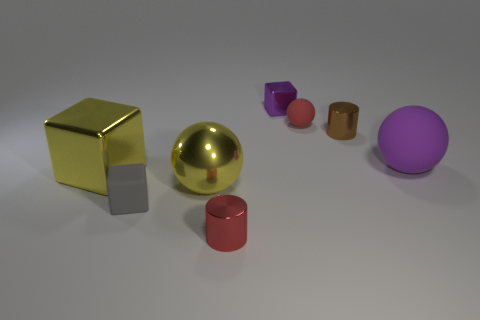Subtract all large yellow cubes. How many cubes are left? 2 Add 2 tiny yellow metal balls. How many objects exist? 10 Subtract all cyan balls. Subtract all gray cubes. How many balls are left? 3 Subtract all spheres. How many objects are left? 5 Subtract all small yellow spheres. Subtract all purple matte balls. How many objects are left? 7 Add 4 purple shiny things. How many purple shiny things are left? 5 Add 2 tiny red matte spheres. How many tiny red matte spheres exist? 3 Subtract 0 blue spheres. How many objects are left? 8 